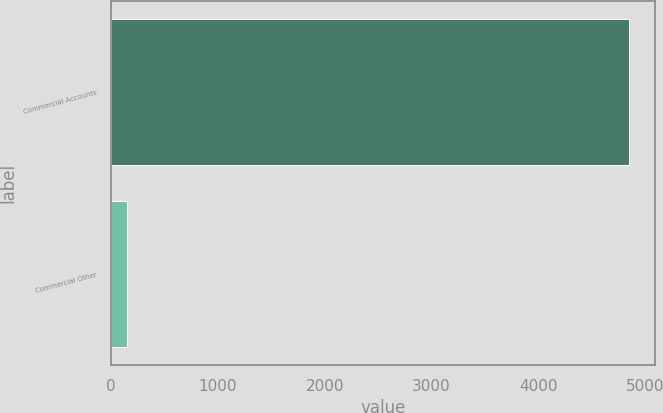Convert chart. <chart><loc_0><loc_0><loc_500><loc_500><bar_chart><fcel>Commercial Accounts<fcel>Commercial Other<nl><fcel>4852<fcel>148<nl></chart> 